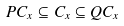Convert formula to latex. <formula><loc_0><loc_0><loc_500><loc_500>P C _ { x } \subseteq C _ { x } \subseteq Q C _ { x }</formula> 